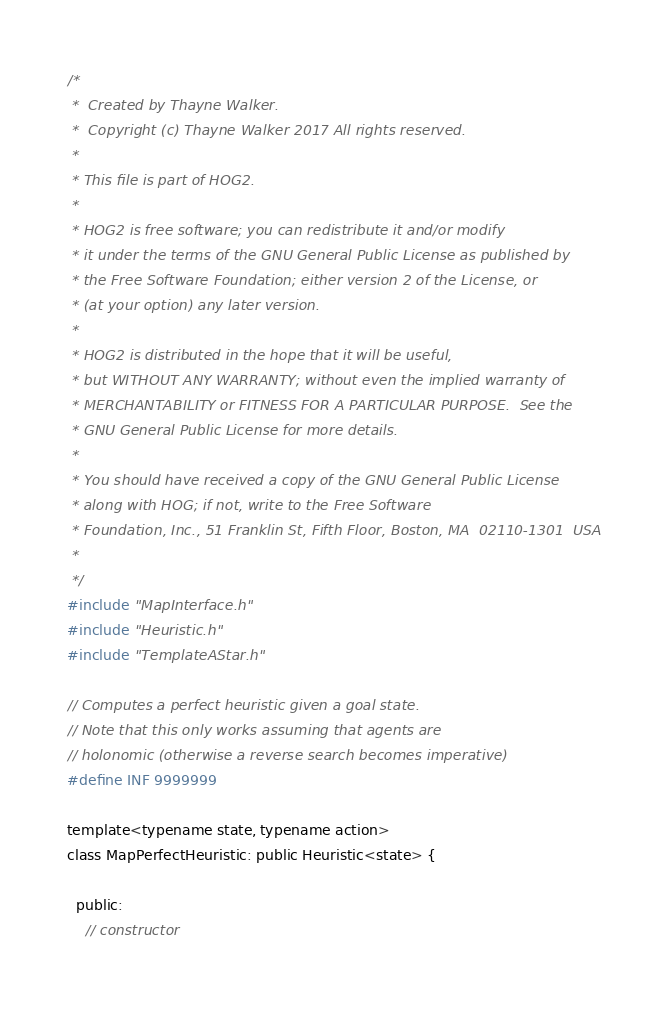Convert code to text. <code><loc_0><loc_0><loc_500><loc_500><_C_>/*
 *  Created by Thayne Walker.
 *  Copyright (c) Thayne Walker 2017 All rights reserved.
 *
 * This file is part of HOG2.
 *
 * HOG2 is free software; you can redistribute it and/or modify
 * it under the terms of the GNU General Public License as published by
 * the Free Software Foundation; either version 2 of the License, or
 * (at your option) any later version.
 * 
 * HOG2 is distributed in the hope that it will be useful,
 * but WITHOUT ANY WARRANTY; without even the implied warranty of
 * MERCHANTABILITY or FITNESS FOR A PARTICULAR PURPOSE.  See the
 * GNU General Public License for more details.
 * 
 * You should have received a copy of the GNU General Public License
 * along with HOG; if not, write to the Free Software
 * Foundation, Inc., 51 Franklin St, Fifth Floor, Boston, MA  02110-1301  USA
 *
 */
#include "MapInterface.h"
#include "Heuristic.h"
#include "TemplateAStar.h"

// Computes a perfect heuristic given a goal state.
// Note that this only works assuming that agents are
// holonomic (otherwise a reverse search becomes imperative)
#define INF 9999999

template<typename state, typename action>
class MapPerfectHeuristic: public Heuristic<state> {

  public:
    // constructor</code> 